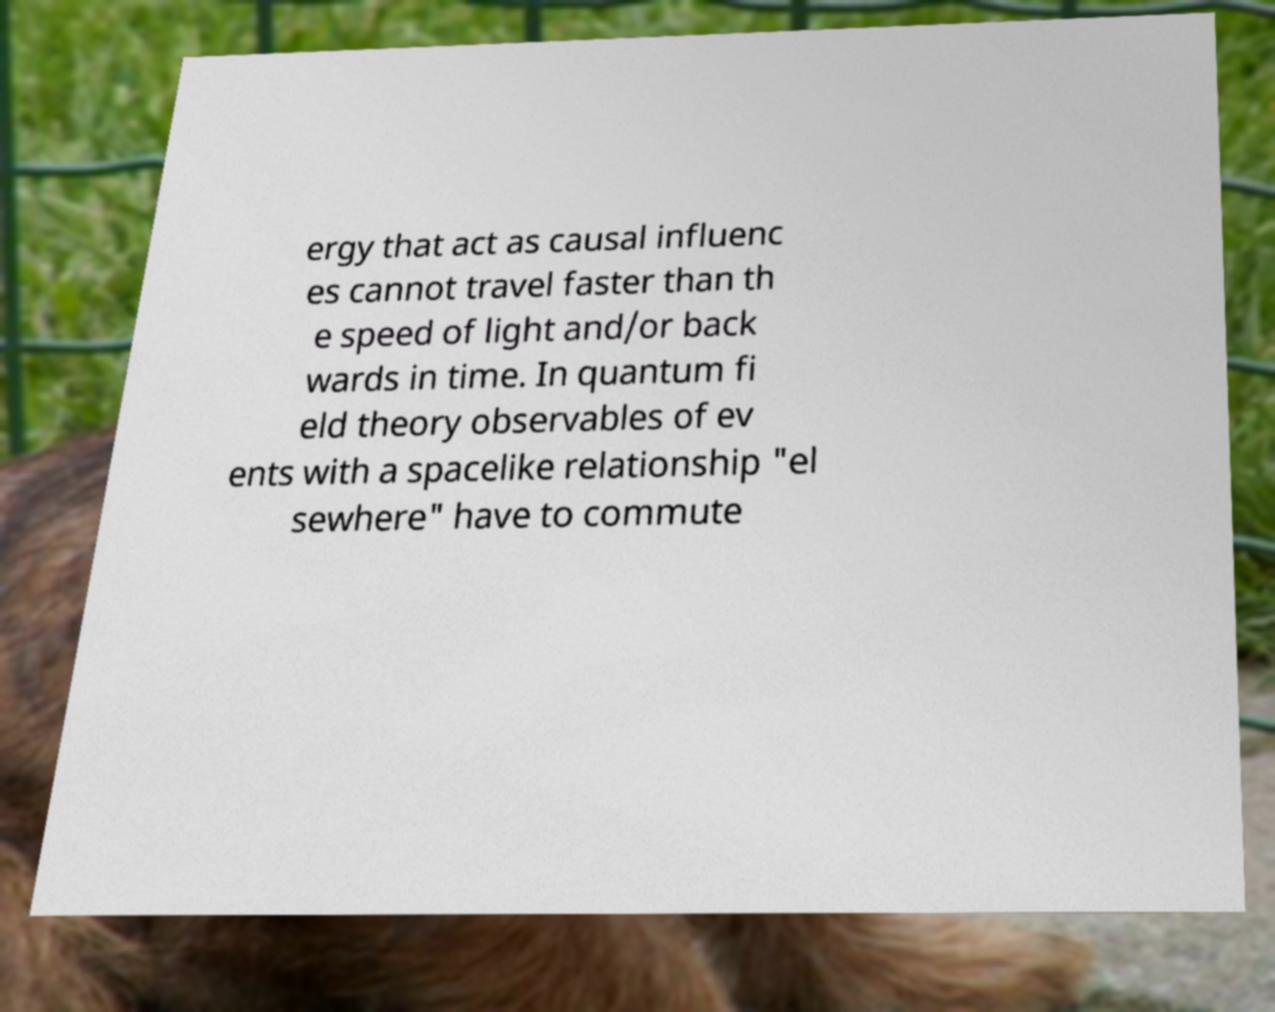For documentation purposes, I need the text within this image transcribed. Could you provide that? ergy that act as causal influenc es cannot travel faster than th e speed of light and/or back wards in time. In quantum fi eld theory observables of ev ents with a spacelike relationship "el sewhere" have to commute 